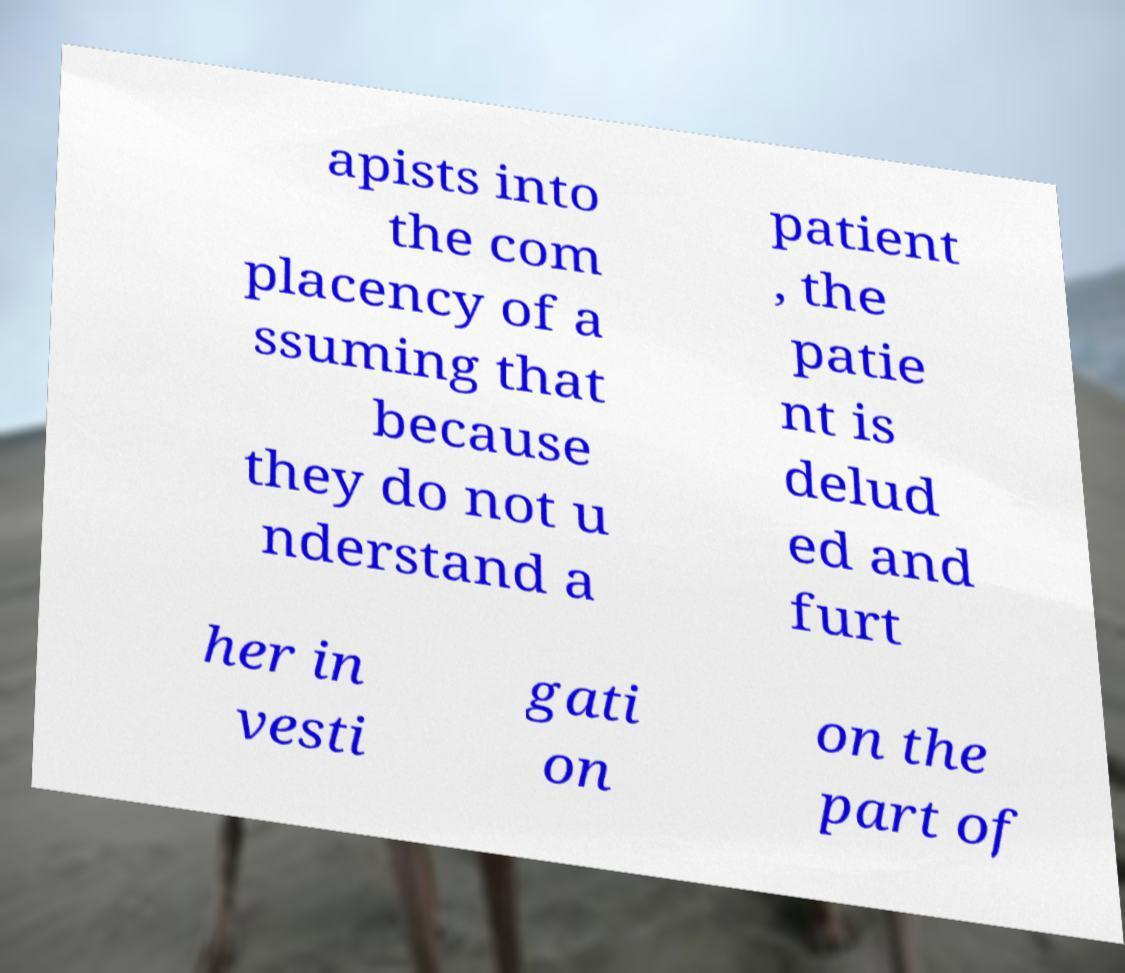Can you accurately transcribe the text from the provided image for me? apists into the com placency of a ssuming that because they do not u nderstand a patient , the patie nt is delud ed and furt her in vesti gati on on the part of 